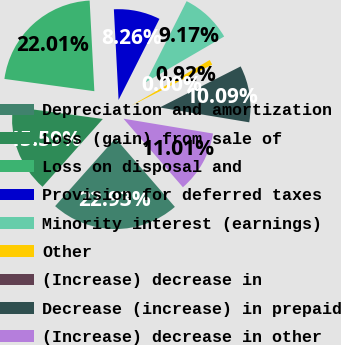<chart> <loc_0><loc_0><loc_500><loc_500><pie_chart><fcel>Depreciation and amortization<fcel>Loss (gain) from sale of<fcel>Loss on disposal and<fcel>Provision for deferred taxes<fcel>Minority interest (earnings)<fcel>Other<fcel>(Increase) decrease in<fcel>Decrease (increase) in prepaid<fcel>(Increase) decrease in other<nl><fcel>22.93%<fcel>15.59%<fcel>22.01%<fcel>8.26%<fcel>9.17%<fcel>0.92%<fcel>0.0%<fcel>10.09%<fcel>11.01%<nl></chart> 